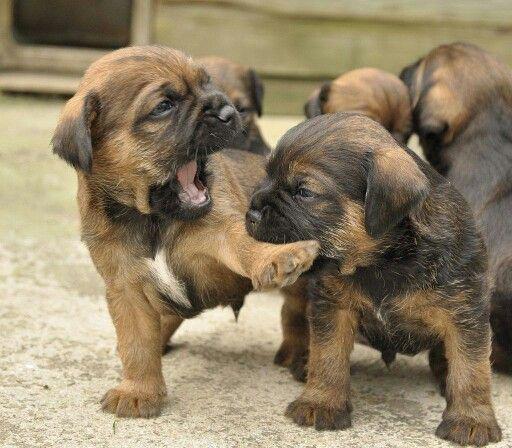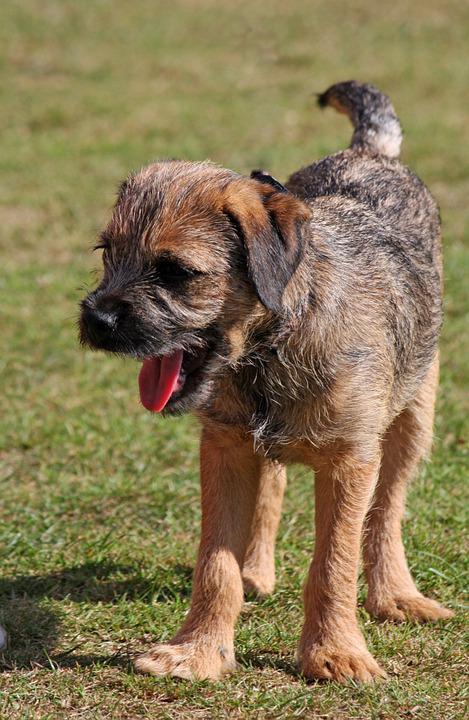The first image is the image on the left, the second image is the image on the right. For the images displayed, is the sentence "There are two dogs" factually correct? Answer yes or no. No. The first image is the image on the left, the second image is the image on the right. Assess this claim about the two images: "All of the images contain only one dog.". Correct or not? Answer yes or no. No. 